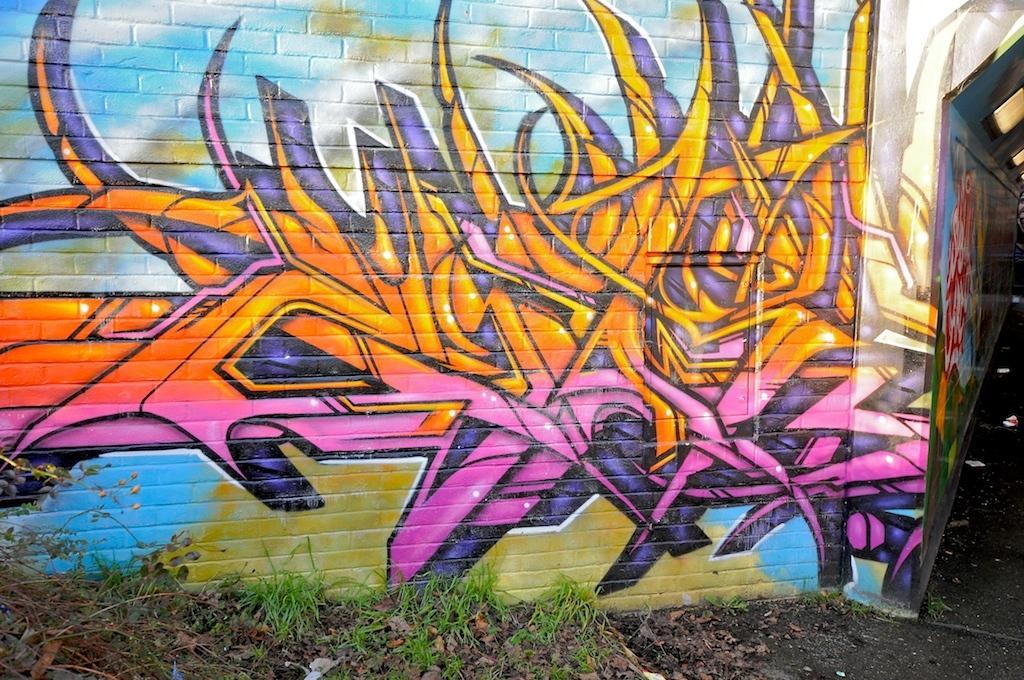In one or two sentences, can you explain what this image depicts? In the background of the image there is a wall on which there is graffiti. At the bottom of the image there are dry leaves and plants. 